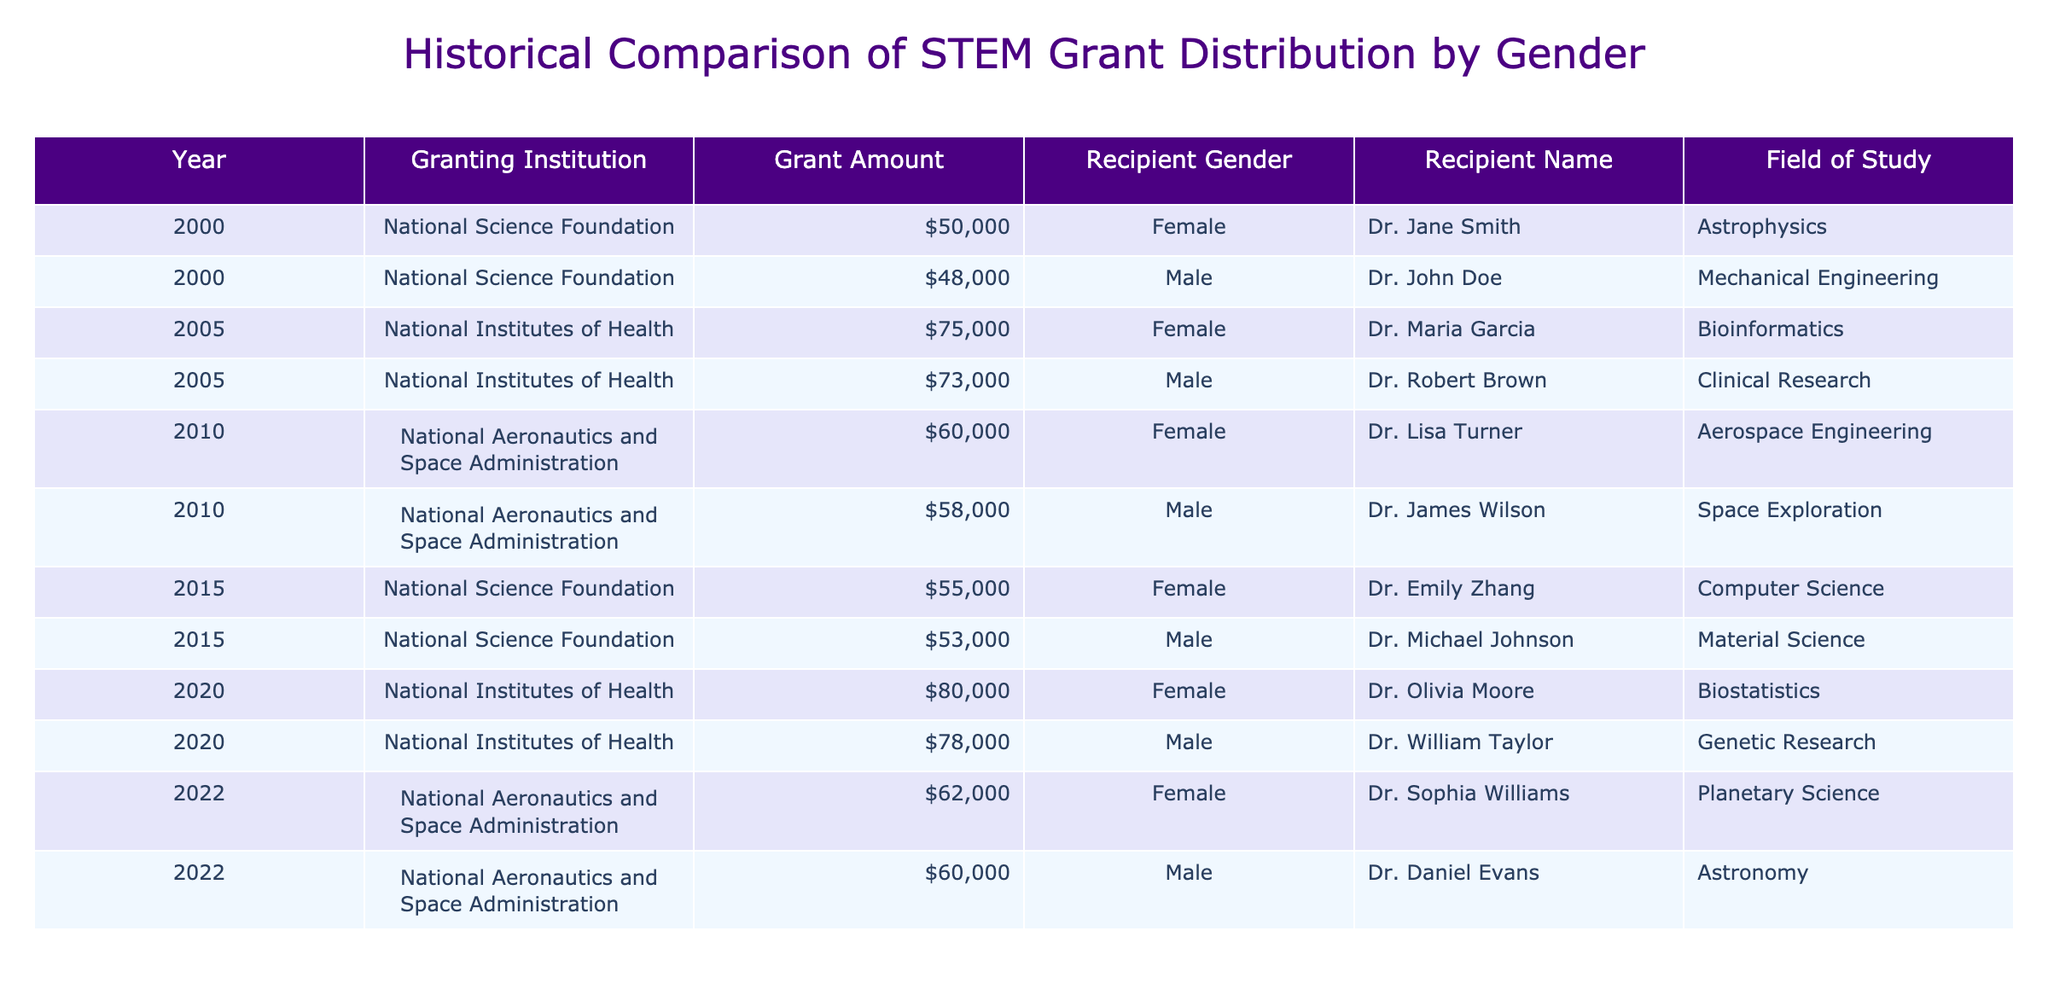What is the total grant amount awarded to female recipients from 2000 to 2022? Summing up the grant amounts for female recipients across the years (50000 + 75000 + 60000 + 55000 + 80000 + 62000) gives us a total of 350000.
Answer: 350000 Which institution awarded the highest grant to a male recipient? Looking through the table, the highest grant awarded to a male recipient is 78000 by the National Institutes of Health to Dr. William Taylor in 2020.
Answer: 78000 Did any female recipients receive a grant greater than 60000 in 2015? In 2015, the only grant amount listed for a female recipient (Dr. Emily Zhang) is 55000, which is not greater than 60000.
Answer: No What percentage of the total grant amounts in 2020 did female recipients receive? The total grant amounts in 2020 were 80000 (female) + 78000 (male) = 158000. The percentage for females is (80000 / 158000) * 100, which is approximately 50.63%.
Answer: 50.63% How many distinct female recipients were awarded grants between 2000 and 2022? The distinct female recipients listed are Dr. Jane Smith, Dr. Maria Garcia, Dr. Lisa Turner, Dr. Emily Zhang, Dr. Olivia Moore, and Dr. Sophia Williams, which totals to 6.
Answer: 6 What is the average grant amount for male recipients across all years? The grant amounts for male recipients are 48000, 73000, 58000, 53000, 78000, and 60000. Summing these gives 390000, and dividing by 6 (the number of male recipients) results in an average of 65000.
Answer: 65000 In which year did female recipients first receive grants, according to the table? The first year reflecting female recipients is 2000, when Dr. Jane Smith received a grant from the National Science Foundation.
Answer: 2000 Were there more grants awarded to male or female recipients in 2010? In 2010, female recipients received 60000, and male recipients received 58000. Thus, there was one grant awarded to a female recipient, which is more than the male grant.
Answer: Female recipients awarded more grants 